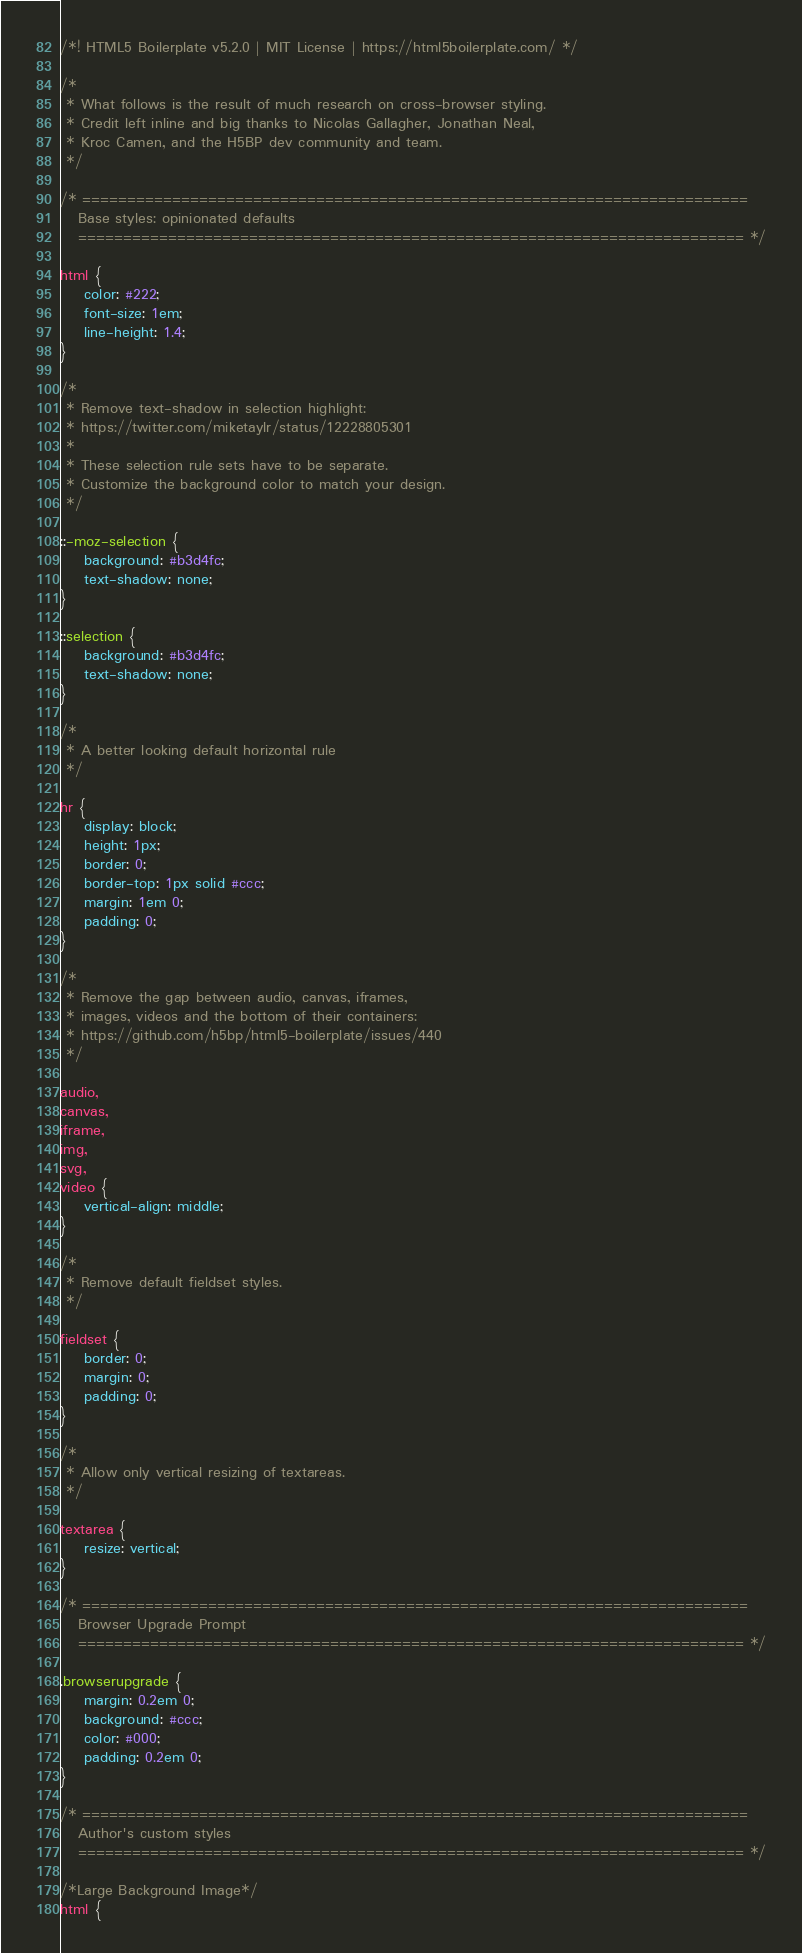Convert code to text. <code><loc_0><loc_0><loc_500><loc_500><_CSS_>/*! HTML5 Boilerplate v5.2.0 | MIT License | https://html5boilerplate.com/ */

/*
 * What follows is the result of much research on cross-browser styling.
 * Credit left inline and big thanks to Nicolas Gallagher, Jonathan Neal,
 * Kroc Camen, and the H5BP dev community and team.
 */

/* ==========================================================================
   Base styles: opinionated defaults
   ========================================================================== */

html {
    color: #222;
    font-size: 1em;
    line-height: 1.4;
}

/*
 * Remove text-shadow in selection highlight:
 * https://twitter.com/miketaylr/status/12228805301
 *
 * These selection rule sets have to be separate.
 * Customize the background color to match your design.
 */

::-moz-selection {
    background: #b3d4fc;
    text-shadow: none;
}

::selection {
    background: #b3d4fc;
    text-shadow: none;
}

/*
 * A better looking default horizontal rule
 */

hr {
    display: block;
    height: 1px;
    border: 0;
    border-top: 1px solid #ccc;
    margin: 1em 0;
    padding: 0;
}

/*
 * Remove the gap between audio, canvas, iframes,
 * images, videos and the bottom of their containers:
 * https://github.com/h5bp/html5-boilerplate/issues/440
 */

audio,
canvas,
iframe,
img,
svg,
video {
    vertical-align: middle;
}

/*
 * Remove default fieldset styles.
 */

fieldset {
    border: 0;
    margin: 0;
    padding: 0;
}

/*
 * Allow only vertical resizing of textareas.
 */

textarea {
    resize: vertical;
}

/* ==========================================================================
   Browser Upgrade Prompt
   ========================================================================== */

.browserupgrade {
    margin: 0.2em 0;
    background: #ccc;
    color: #000;
    padding: 0.2em 0;
}

/* ==========================================================================
   Author's custom styles
   ========================================================================== */

/*Large Background Image*/
html {</code> 